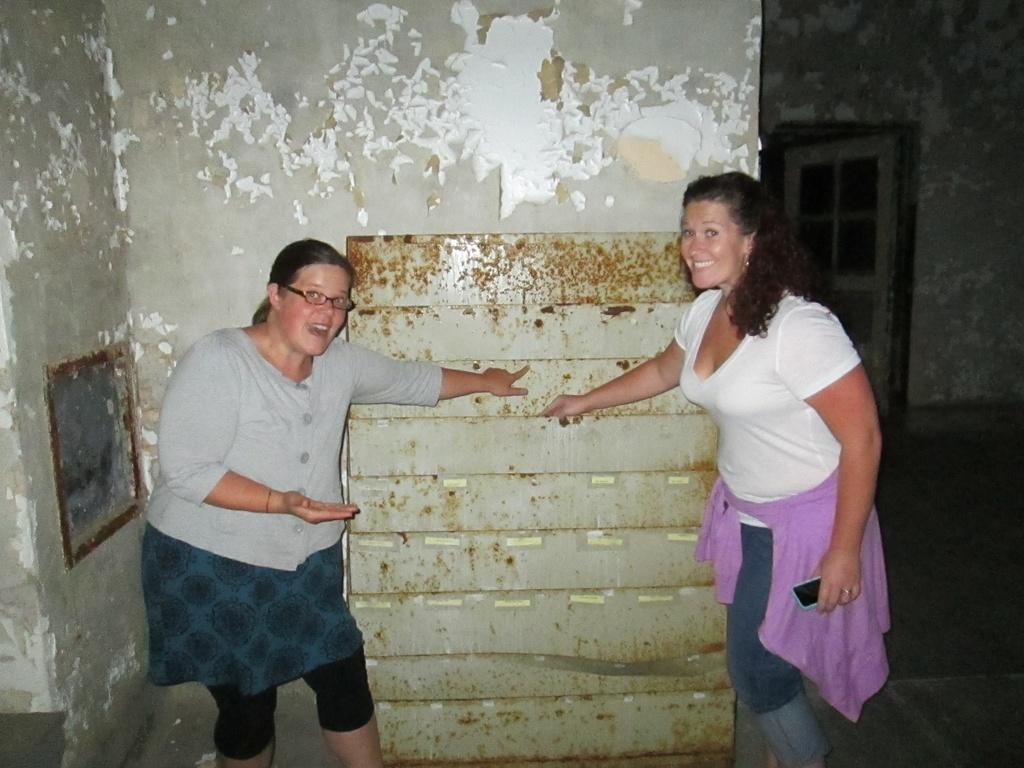Who is in the front of the image? There are women standing in the front of the image. What expression do the women have? The women are smiling. What can be seen in the background of the image? There is a wall in the background of the image, and on the wall, there is a frame and a door. What type of wristwatch is visible on the women's wrists in the image? There is no wristwatch visible on the women's wrists in the image. How many drops of water can be seen falling from the ceiling in the image? There are no drops of water visible in the image. 